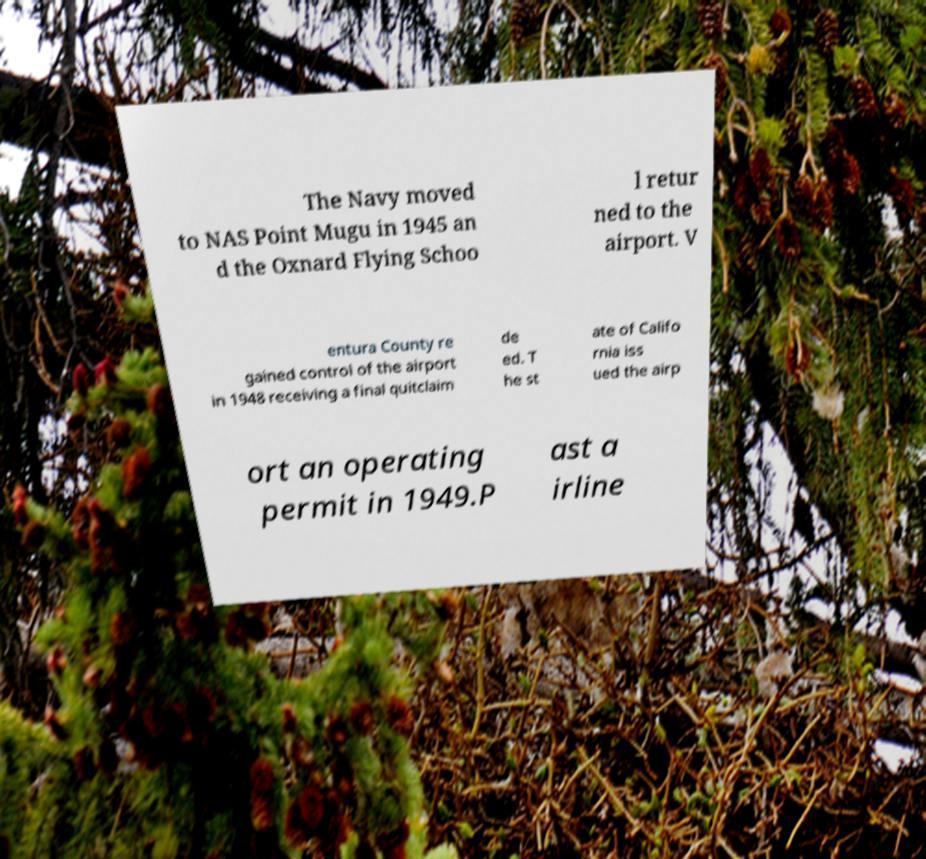For documentation purposes, I need the text within this image transcribed. Could you provide that? The Navy moved to NAS Point Mugu in 1945 an d the Oxnard Flying Schoo l retur ned to the airport. V entura County re gained control of the airport in 1948 receiving a final quitclaim de ed. T he st ate of Califo rnia iss ued the airp ort an operating permit in 1949.P ast a irline 